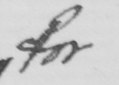What text is written in this handwritten line? for 